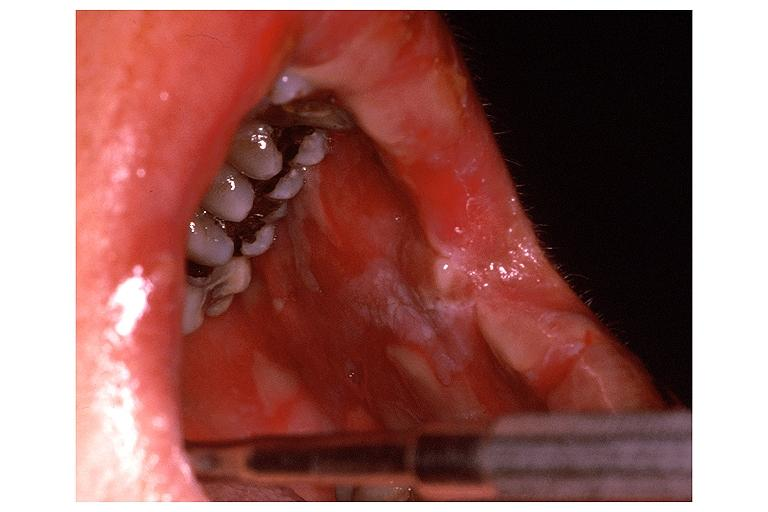s squamous cell carcinoma present?
Answer the question using a single word or phrase. No 